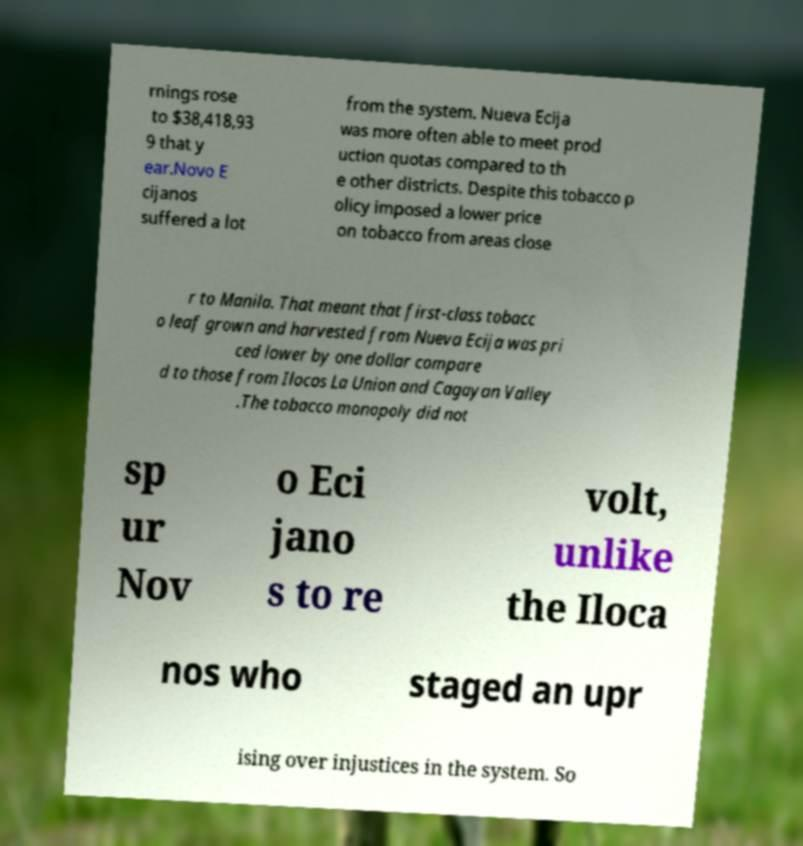Please read and relay the text visible in this image. What does it say? rnings rose to $38,418,93 9 that y ear.Novo E cijanos suffered a lot from the system. Nueva Ecija was more often able to meet prod uction quotas compared to th e other districts. Despite this tobacco p olicy imposed a lower price on tobacco from areas close r to Manila. That meant that first-class tobacc o leaf grown and harvested from Nueva Ecija was pri ced lower by one dollar compare d to those from Ilocos La Union and Cagayan Valley .The tobacco monopoly did not sp ur Nov o Eci jano s to re volt, unlike the Iloca nos who staged an upr ising over injustices in the system. So 